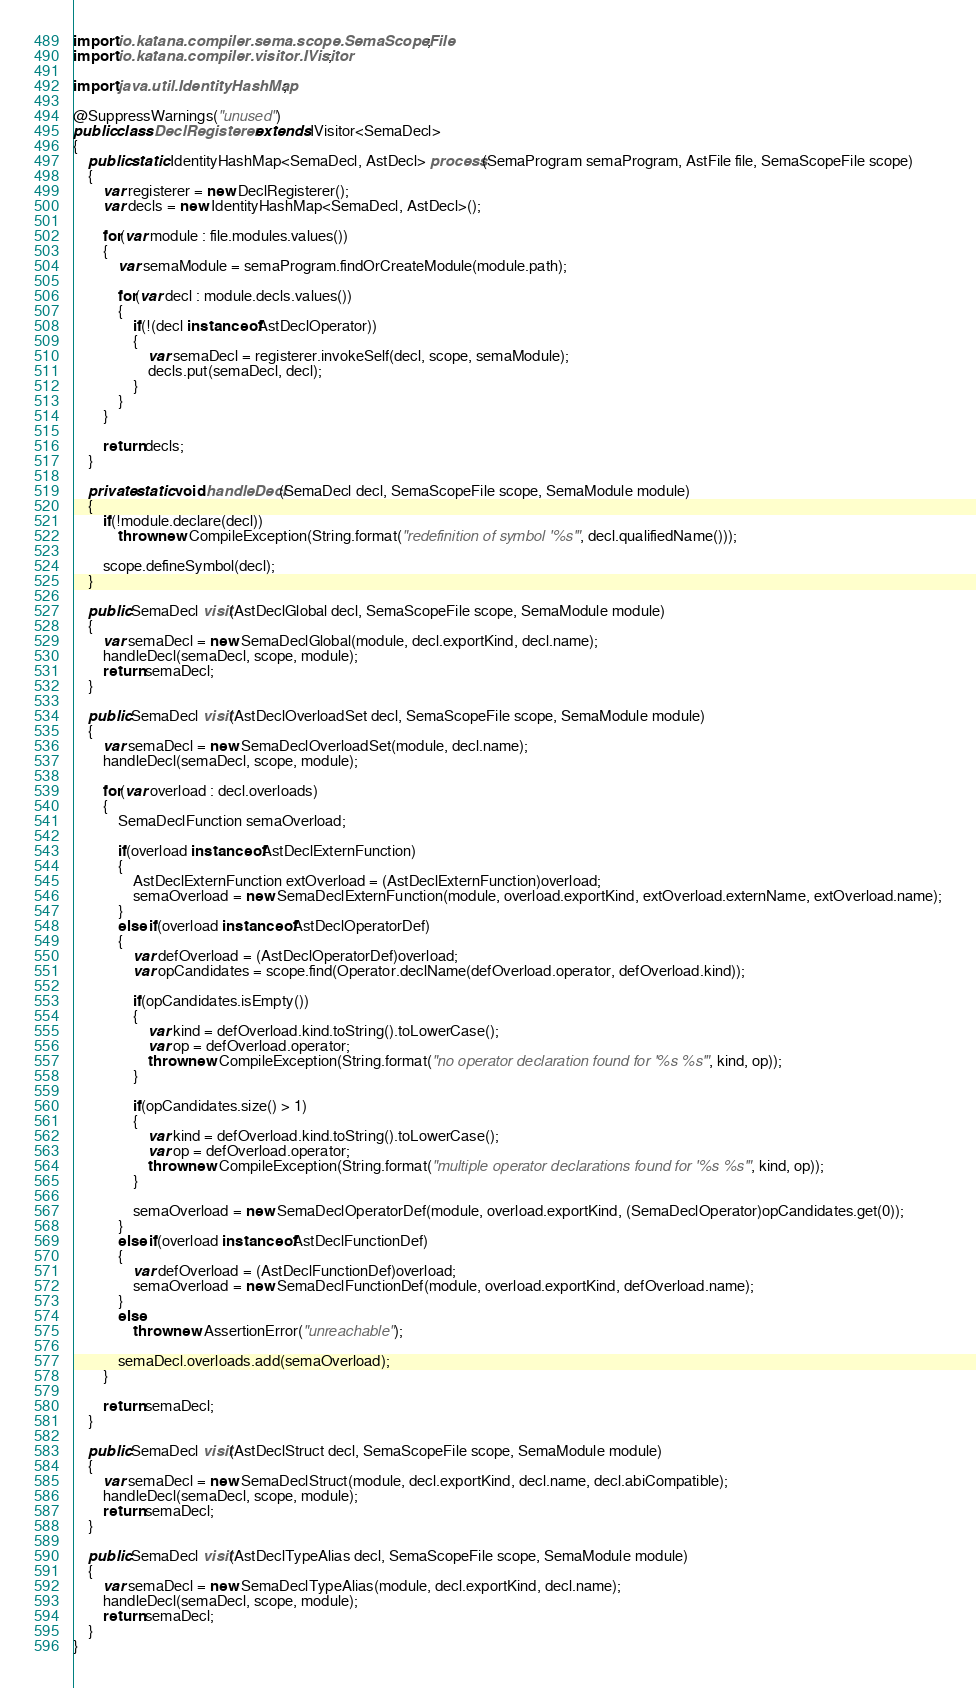<code> <loc_0><loc_0><loc_500><loc_500><_Java_>import io.katana.compiler.sema.scope.SemaScopeFile;
import io.katana.compiler.visitor.IVisitor;

import java.util.IdentityHashMap;

@SuppressWarnings("unused")
public class DeclRegisterer extends IVisitor<SemaDecl>
{
	public static IdentityHashMap<SemaDecl, AstDecl> process(SemaProgram semaProgram, AstFile file, SemaScopeFile scope)
	{
		var registerer = new DeclRegisterer();
		var decls = new IdentityHashMap<SemaDecl, AstDecl>();

		for(var module : file.modules.values())
		{
			var semaModule = semaProgram.findOrCreateModule(module.path);

			for(var decl : module.decls.values())
			{
				if(!(decl instanceof AstDeclOperator))
				{
					var semaDecl = registerer.invokeSelf(decl, scope, semaModule);
					decls.put(semaDecl, decl);
				}
			}
		}

		return decls;
	}

	private static void handleDecl(SemaDecl decl, SemaScopeFile scope, SemaModule module)
	{
		if(!module.declare(decl))
			throw new CompileException(String.format("redefinition of symbol '%s'", decl.qualifiedName()));

		scope.defineSymbol(decl);
	}

	public SemaDecl visit(AstDeclGlobal decl, SemaScopeFile scope, SemaModule module)
	{
		var semaDecl = new SemaDeclGlobal(module, decl.exportKind, decl.name);
		handleDecl(semaDecl, scope, module);
		return semaDecl;
	}

	public SemaDecl visit(AstDeclOverloadSet decl, SemaScopeFile scope, SemaModule module)
	{
		var semaDecl = new SemaDeclOverloadSet(module, decl.name);
		handleDecl(semaDecl, scope, module);

		for(var overload : decl.overloads)
		{
			SemaDeclFunction semaOverload;

			if(overload instanceof AstDeclExternFunction)
			{
				AstDeclExternFunction extOverload = (AstDeclExternFunction)overload;
				semaOverload = new SemaDeclExternFunction(module, overload.exportKind, extOverload.externName, extOverload.name);
			}
			else if(overload instanceof AstDeclOperatorDef)
			{
				var defOverload = (AstDeclOperatorDef)overload;
				var opCandidates = scope.find(Operator.declName(defOverload.operator, defOverload.kind));

				if(opCandidates.isEmpty())
				{
					var kind = defOverload.kind.toString().toLowerCase();
					var op = defOverload.operator;
					throw new CompileException(String.format("no operator declaration found for '%s %s'", kind, op));
				}

				if(opCandidates.size() > 1)
				{
					var kind = defOverload.kind.toString().toLowerCase();
					var op = defOverload.operator;
					throw new CompileException(String.format("multiple operator declarations found for '%s %s'", kind, op));
				}

				semaOverload = new SemaDeclOperatorDef(module, overload.exportKind, (SemaDeclOperator)opCandidates.get(0));
			}
			else if(overload instanceof AstDeclFunctionDef)
			{
				var defOverload = (AstDeclFunctionDef)overload;
				semaOverload = new SemaDeclFunctionDef(module, overload.exportKind, defOverload.name);
			}
			else
				throw new AssertionError("unreachable");

			semaDecl.overloads.add(semaOverload);
		}

		return semaDecl;
	}

	public SemaDecl visit(AstDeclStruct decl, SemaScopeFile scope, SemaModule module)
	{
		var semaDecl = new SemaDeclStruct(module, decl.exportKind, decl.name, decl.abiCompatible);
		handleDecl(semaDecl, scope, module);
		return semaDecl;
	}

	public SemaDecl visit(AstDeclTypeAlias decl, SemaScopeFile scope, SemaModule module)
	{
		var semaDecl = new SemaDeclTypeAlias(module, decl.exportKind, decl.name);
		handleDecl(semaDecl, scope, module);
		return semaDecl;
	}
}
</code> 